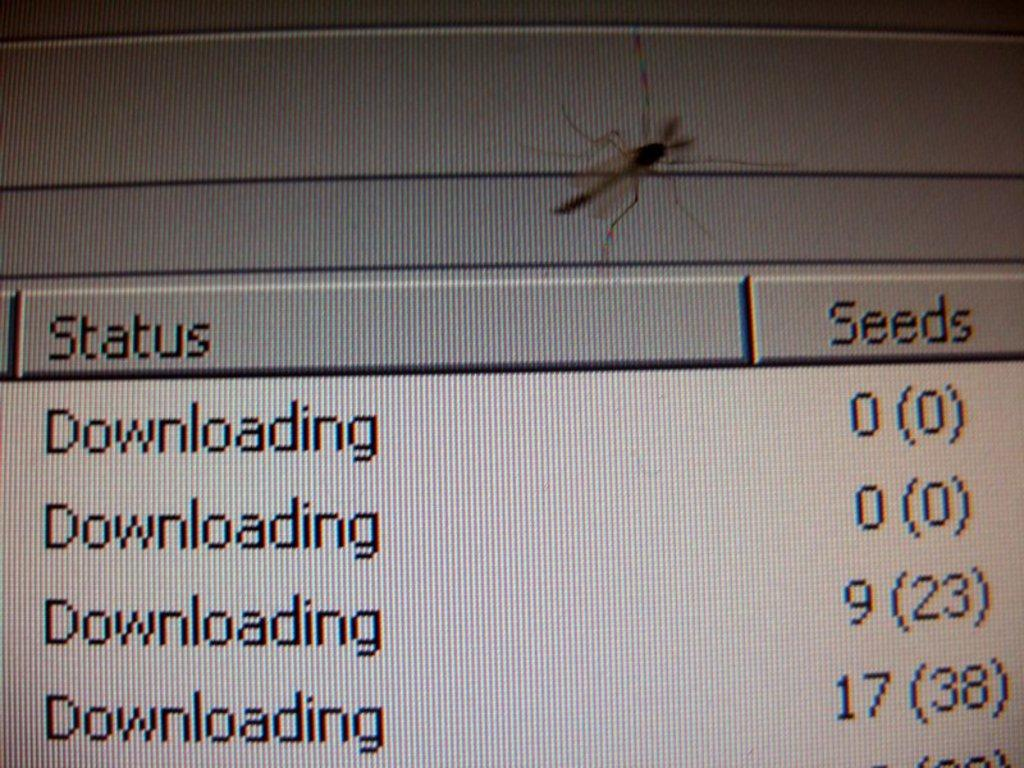What is present in the image? There is an insect in the image. Where is the insect located? The insect is on a screen. What else can be seen on the screen besides the insect? There is text or writing on the screen. What type of muscle can be seen in the image? There is no muscle present in the image; it features an insect on a screen with text or writing. 